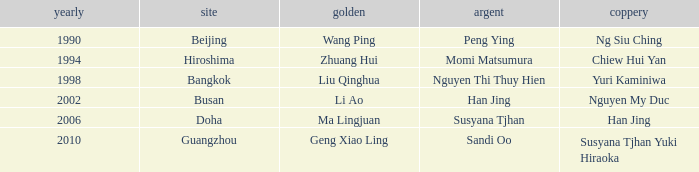What Gold has the Year of 2006? Ma Lingjuan. 